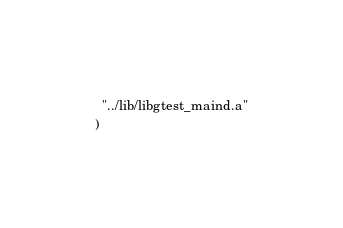Convert code to text. <code><loc_0><loc_0><loc_500><loc_500><_CMake_>  "../lib/libgtest_maind.a"
)
</code> 